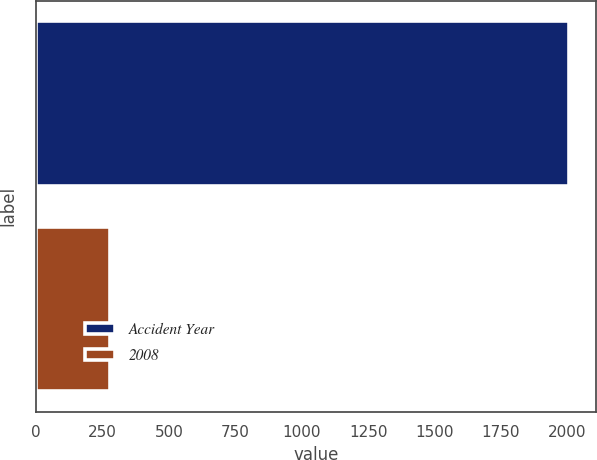Convert chart to OTSL. <chart><loc_0><loc_0><loc_500><loc_500><bar_chart><fcel>Accident Year<fcel>2008<nl><fcel>2008<fcel>280<nl></chart> 